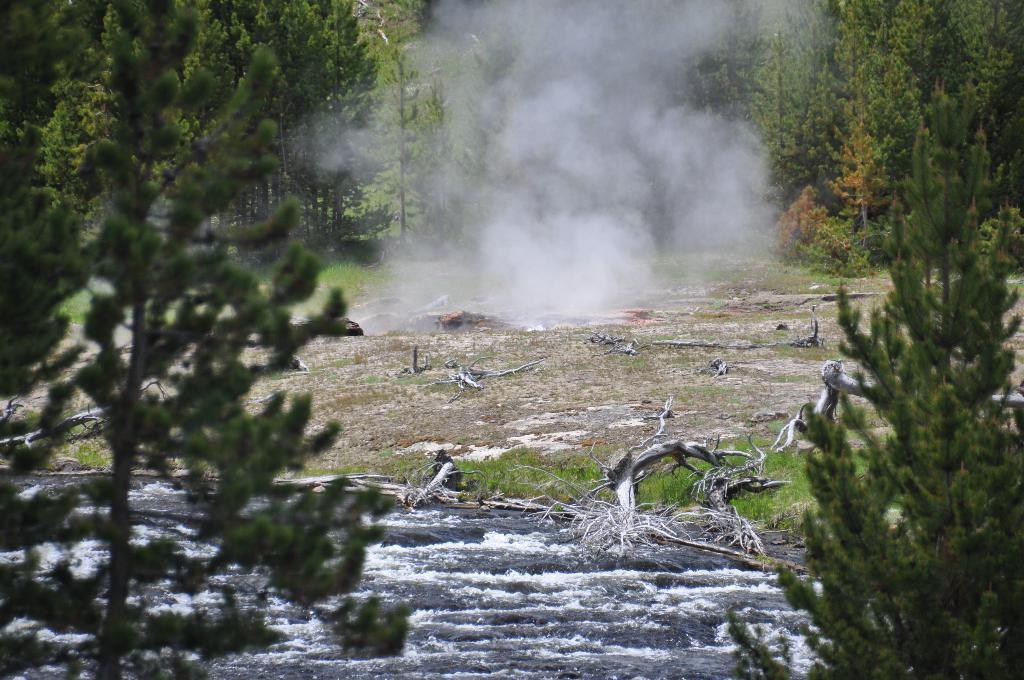Please provide a concise description of this image. In this image there are trees and we can see logs. At the bottom there is a rock and we can see grass. There is smoke. 